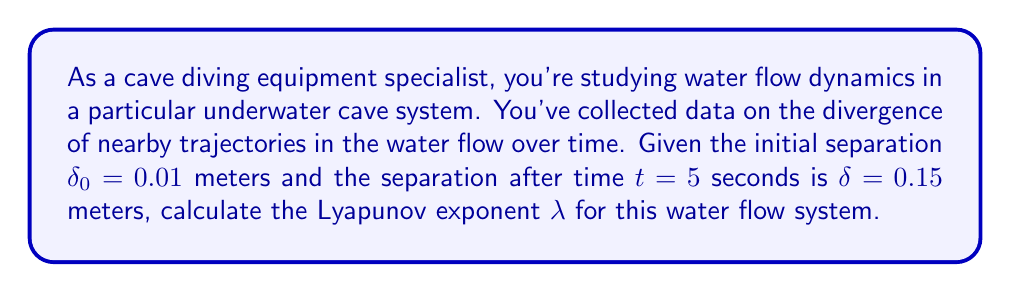Help me with this question. To calculate the Lyapunov exponent $\lambda$ for the water flow dynamics in this cave system, we'll follow these steps:

1) The Lyapunov exponent is defined by the equation:

   $$\lambda = \lim_{t \to \infty} \frac{1}{t} \ln\left(\frac{\delta(t)}{\delta_0}\right)$$

   where $\delta(t)$ is the separation after time $t$, and $\delta_0$ is the initial separation.

2) We're given:
   $\delta_0 = 0.01$ meters
   $\delta(5) = 0.15$ meters
   $t = 5$ seconds

3) Substituting these values into the equation:

   $$\lambda \approx \frac{1}{5} \ln\left(\frac{0.15}{0.01}\right)$$

4) Simplify inside the logarithm:

   $$\lambda \approx \frac{1}{5} \ln(15)$$

5) Calculate the natural logarithm:

   $$\lambda \approx \frac{1}{5} \cdot 2.70805$$

6) Perform the final division:

   $$\lambda \approx 0.54161$$

Thus, the Lyapunov exponent for this water flow system is approximately 0.54161 s^(-1).
Answer: $\lambda \approx 0.54161$ s^(-1) 